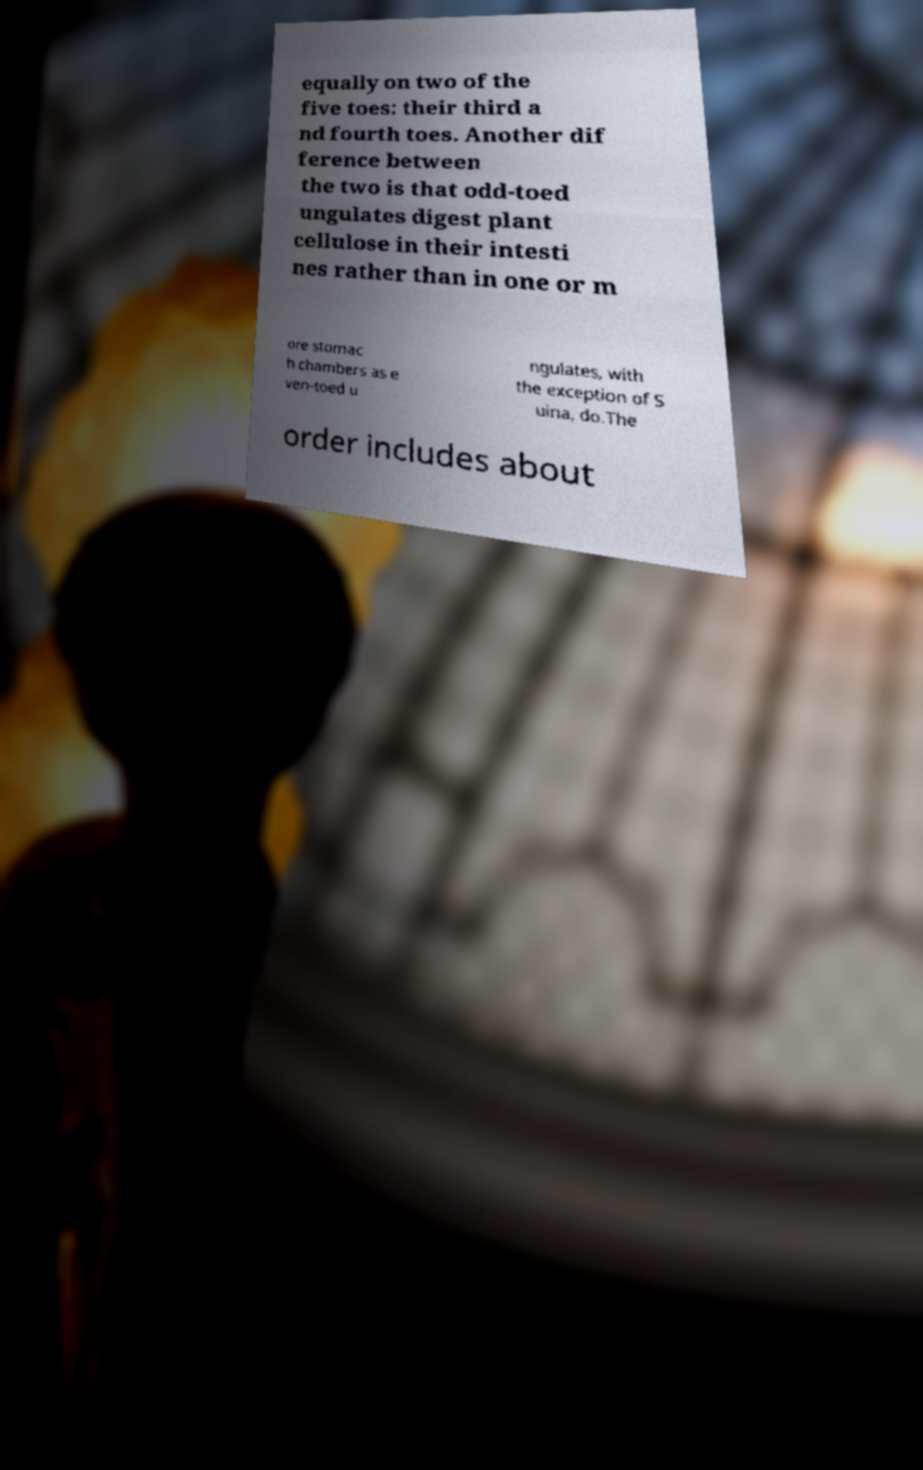Can you read and provide the text displayed in the image?This photo seems to have some interesting text. Can you extract and type it out for me? equally on two of the five toes: their third a nd fourth toes. Another dif ference between the two is that odd-toed ungulates digest plant cellulose in their intesti nes rather than in one or m ore stomac h chambers as e ven-toed u ngulates, with the exception of S uina, do.The order includes about 